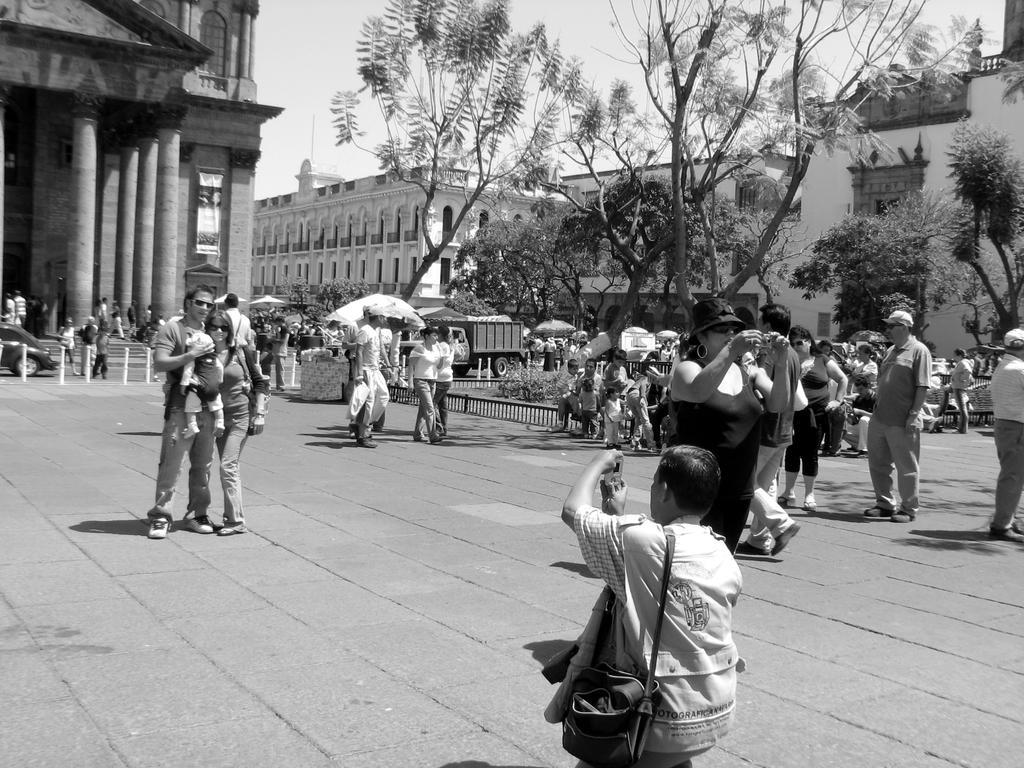Can you describe this image briefly? This is a black and white image where I can see a person carrying bag is holding a camera and clicking the pictures. In the background, we can see many people among them few are walking on the road, few are standing and few are sitting, I can see trees, I can see vehicles moving on the road, I can see the pillars, buildings, and the sky. 